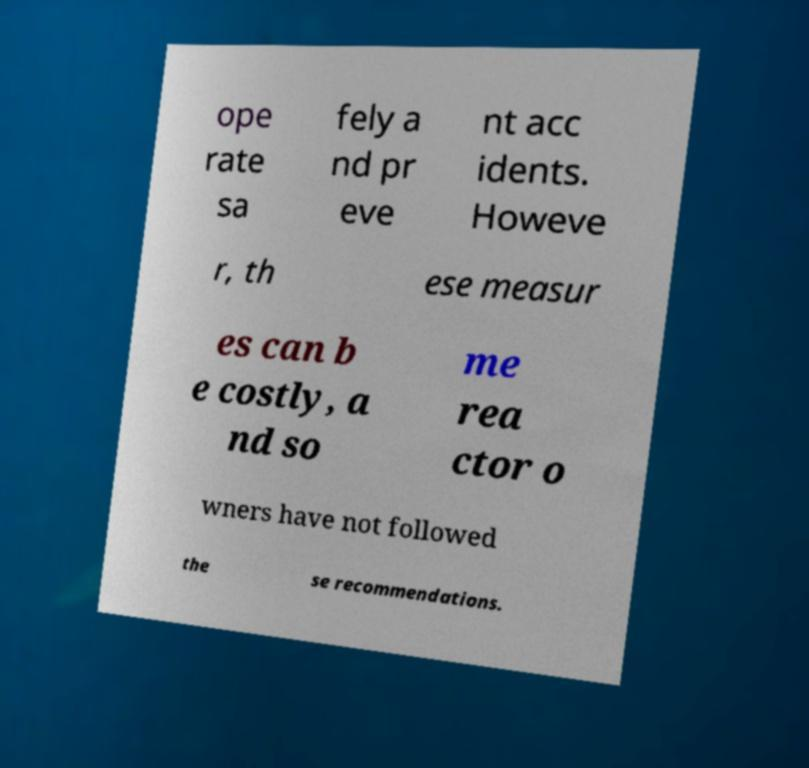Can you read and provide the text displayed in the image?This photo seems to have some interesting text. Can you extract and type it out for me? ope rate sa fely a nd pr eve nt acc idents. Howeve r, th ese measur es can b e costly, a nd so me rea ctor o wners have not followed the se recommendations. 